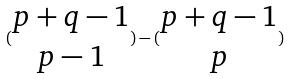Convert formula to latex. <formula><loc_0><loc_0><loc_500><loc_500>( \begin{matrix} p + q - 1 \\ p - 1 \end{matrix} ) - ( \begin{matrix} p + q - 1 \\ p \end{matrix} )</formula> 